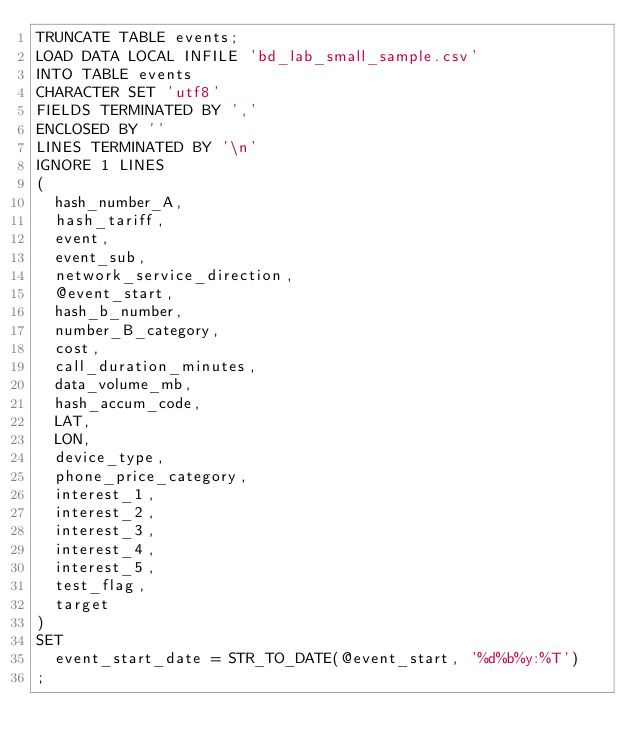Convert code to text. <code><loc_0><loc_0><loc_500><loc_500><_SQL_>TRUNCATE TABLE events;
LOAD DATA LOCAL INFILE 'bd_lab_small_sample.csv'
INTO TABLE events
CHARACTER SET 'utf8'
FIELDS TERMINATED BY ','
ENCLOSED BY ''
LINES TERMINATED BY '\n'
IGNORE 1 LINES
(
	hash_number_A,
	hash_tariff,
	event,
	event_sub,
	network_service_direction,
	@event_start,
	hash_b_number,
	number_B_category,
	cost,
	call_duration_minutes,
	data_volume_mb,
	hash_accum_code,
	LAT,
	LON,
	device_type,
	phone_price_category,
	interest_1,
	interest_2,
	interest_3,
	interest_4,
	interest_5,
	test_flag,
	target
)
SET
	event_start_date = STR_TO_DATE(@event_start, '%d%b%y:%T')
;

</code> 